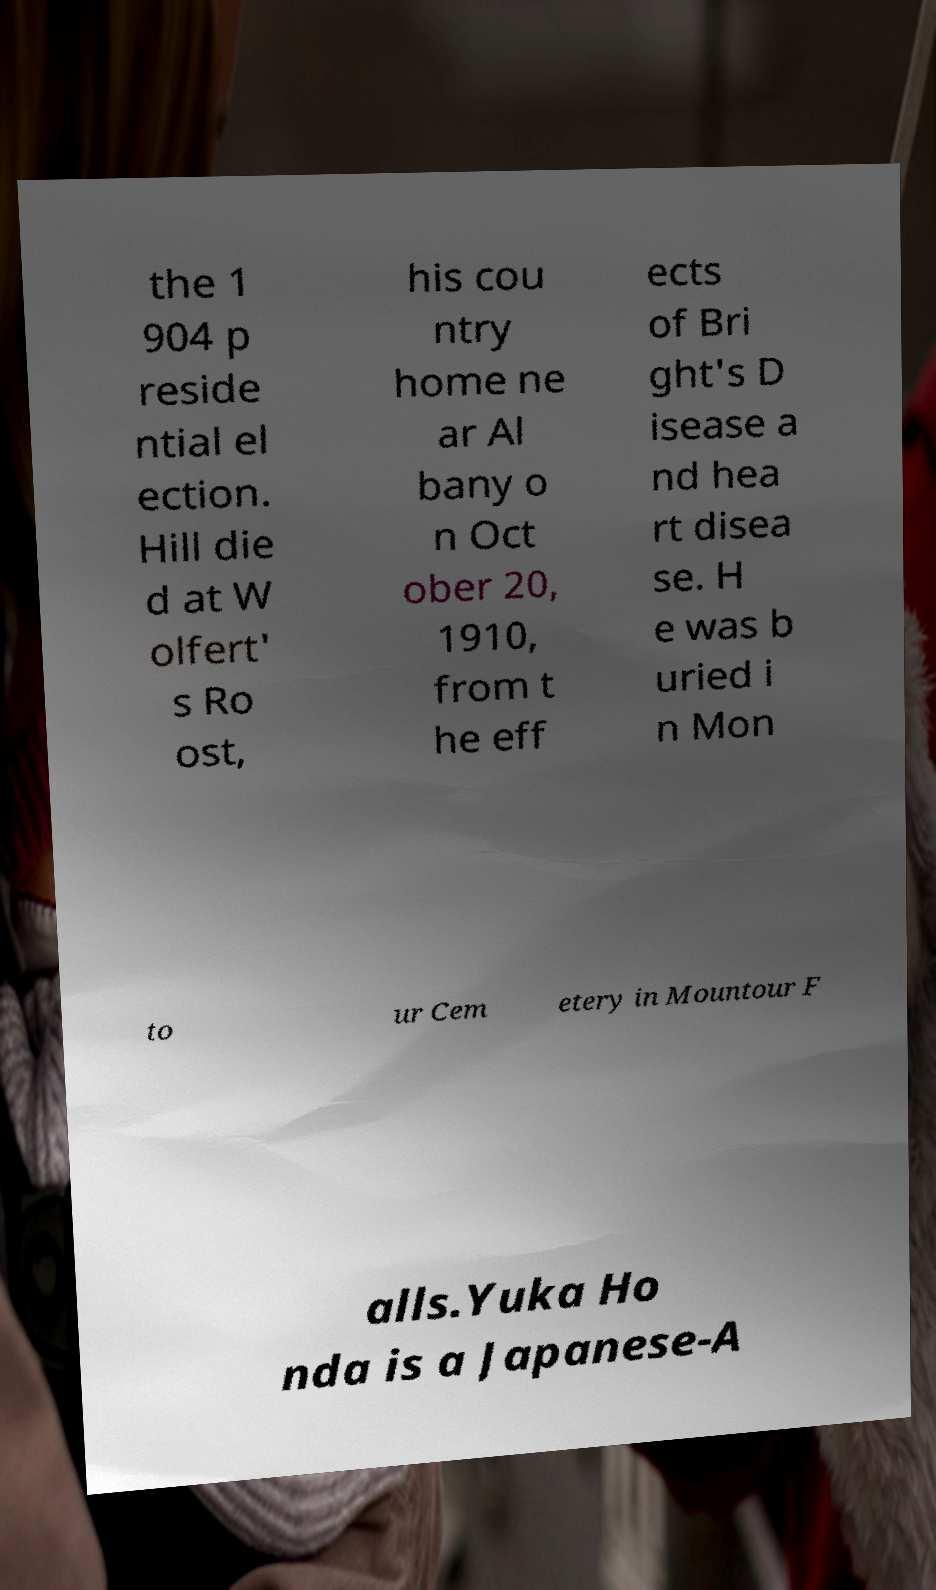I need the written content from this picture converted into text. Can you do that? the 1 904 p reside ntial el ection. Hill die d at W olfert' s Ro ost, his cou ntry home ne ar Al bany o n Oct ober 20, 1910, from t he eff ects of Bri ght's D isease a nd hea rt disea se. H e was b uried i n Mon to ur Cem etery in Mountour F alls.Yuka Ho nda is a Japanese-A 